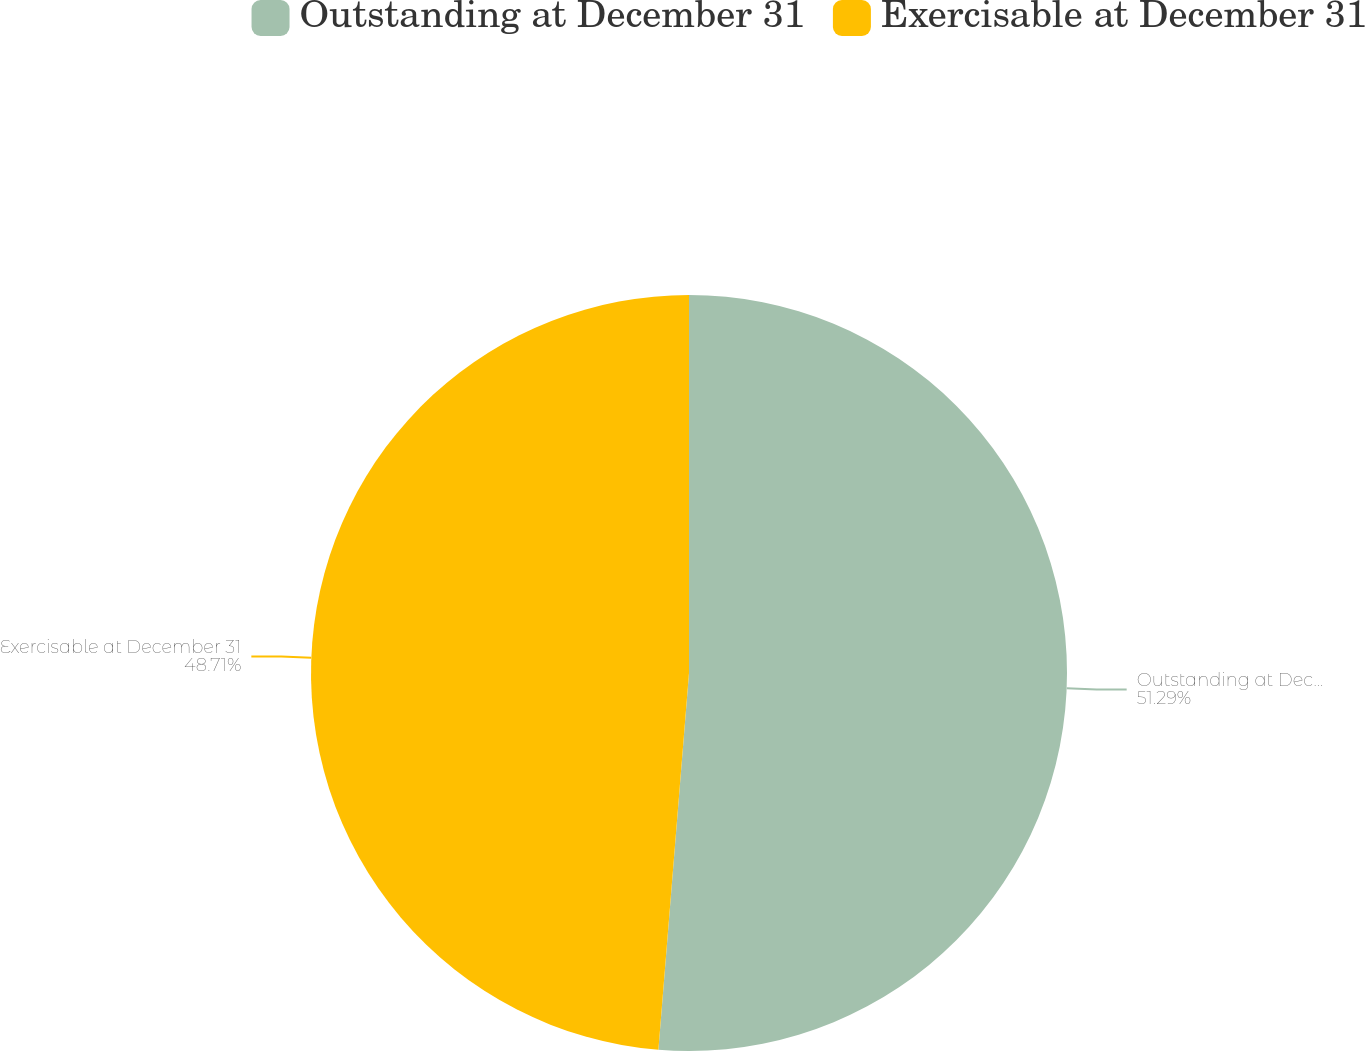Convert chart to OTSL. <chart><loc_0><loc_0><loc_500><loc_500><pie_chart><fcel>Outstanding at December 31<fcel>Exercisable at December 31<nl><fcel>51.29%<fcel>48.71%<nl></chart> 